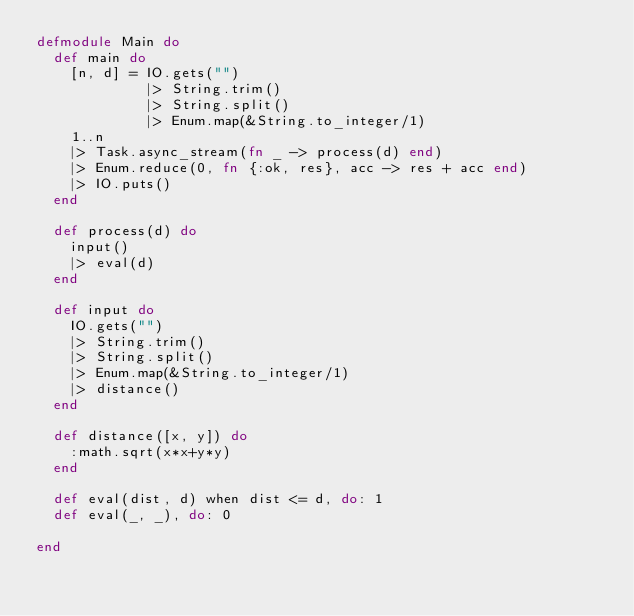<code> <loc_0><loc_0><loc_500><loc_500><_Elixir_>defmodule Main do
  def main do
    [n, d] = IO.gets("")
             |> String.trim()
             |> String.split()
             |> Enum.map(&String.to_integer/1)
    1..n
    |> Task.async_stream(fn _ -> process(d) end)
    |> Enum.reduce(0, fn {:ok, res}, acc -> res + acc end)
    |> IO.puts()
  end

  def process(d) do
    input()
    |> eval(d)
  end

  def input do
    IO.gets("")
    |> String.trim()
    |> String.split()
    |> Enum.map(&String.to_integer/1)
    |> distance()
  end

  def distance([x, y]) do
    :math.sqrt(x*x+y*y)
  end

  def eval(dist, d) when dist <= d, do: 1
  def eval(_, _), do: 0

end
</code> 